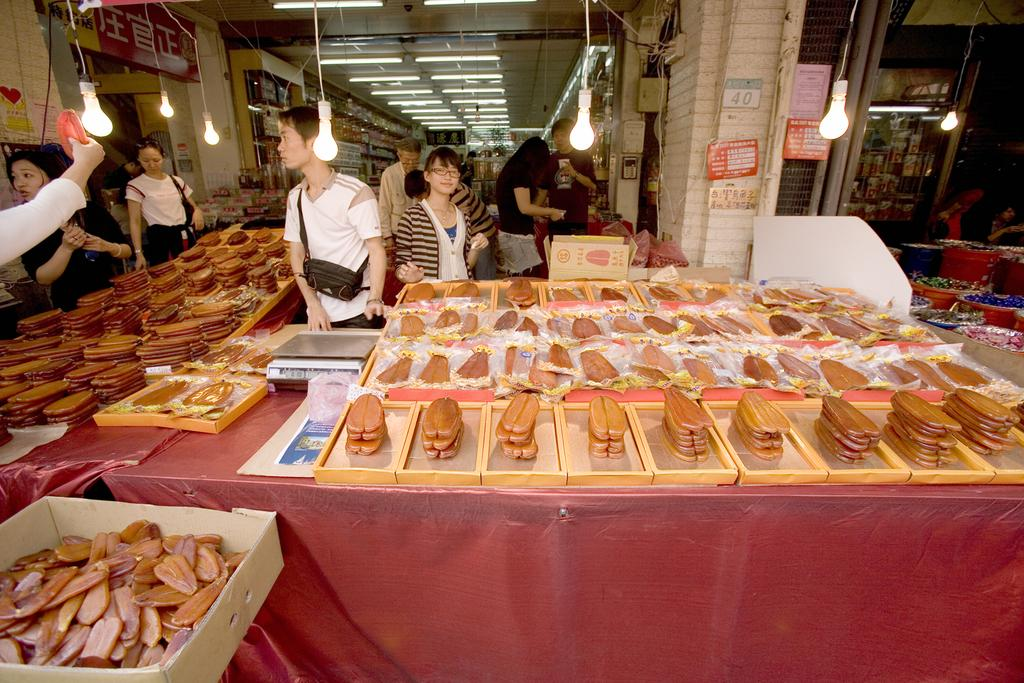How many people can be seen in the image? There are people in the image, but the exact number cannot be determined from the provided facts. What items are present in the image that might be used for carrying or storing things? There are bags and boxes in the image that can be used for carrying or storing things. What type of furniture is visible in the image? There are trays on tables in the image, which suggests the presence of tables. What type of decorative items are visible in the image? There are posters in the image, which can be considered decorative items. What type of infrastructure is visible in the image? There are pipes in the image, which suggests the presence of some infrastructure. What type of background can be seen in the image? There is a wall in the image, and lights and a ceiling are visible in the background. What time is the operation scheduled to begin in the image? There is no mention of an operation or a specific time in the image, so this question cannot be answered definitively. 